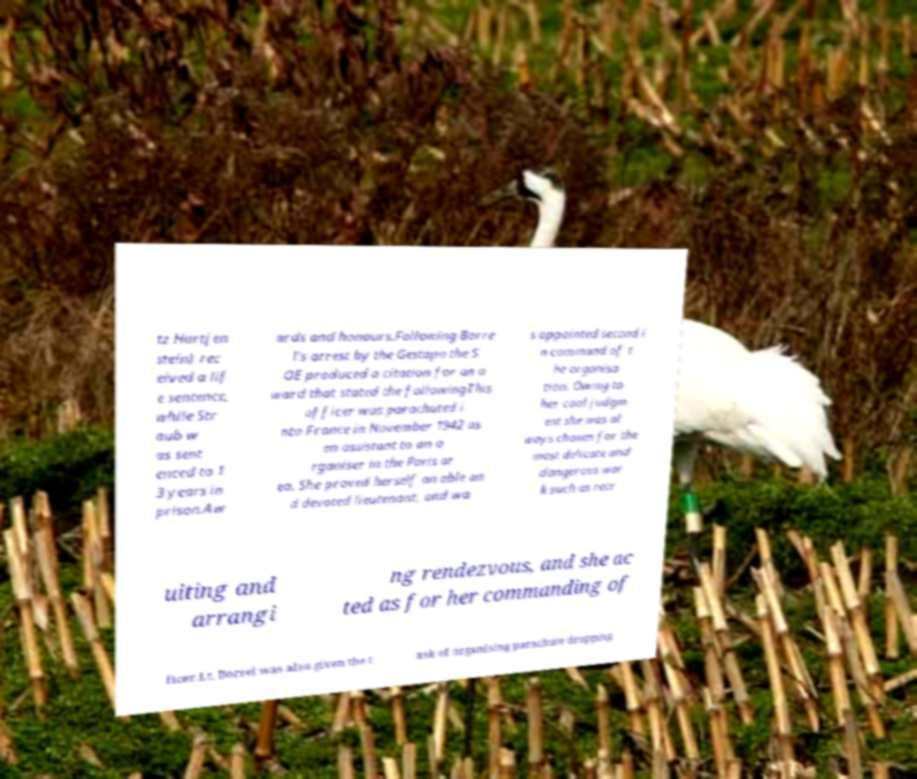Please read and relay the text visible in this image. What does it say? tz Hartjen stein) rec eived a lif e sentence, while Str aub w as sent enced to 1 3 years in prison.Aw ards and honours.Following Borre l's arrest by the Gestapo the S OE produced a citation for an a ward that stated the followingThis officer was parachuted i nto France in November 1942 as an assistant to an o rganiser in the Paris ar ea. She proved herself an able an d devoted lieutenant, and wa s appointed second i n command of t he organisa tion. Owing to her cool judgm ent she was al ways chosen for the most delicate and dangerous wor k such as recr uiting and arrangi ng rendezvous, and she ac ted as for her commanding of ficer.Lt. Borrel was also given the t ask of organising parachute dropping 